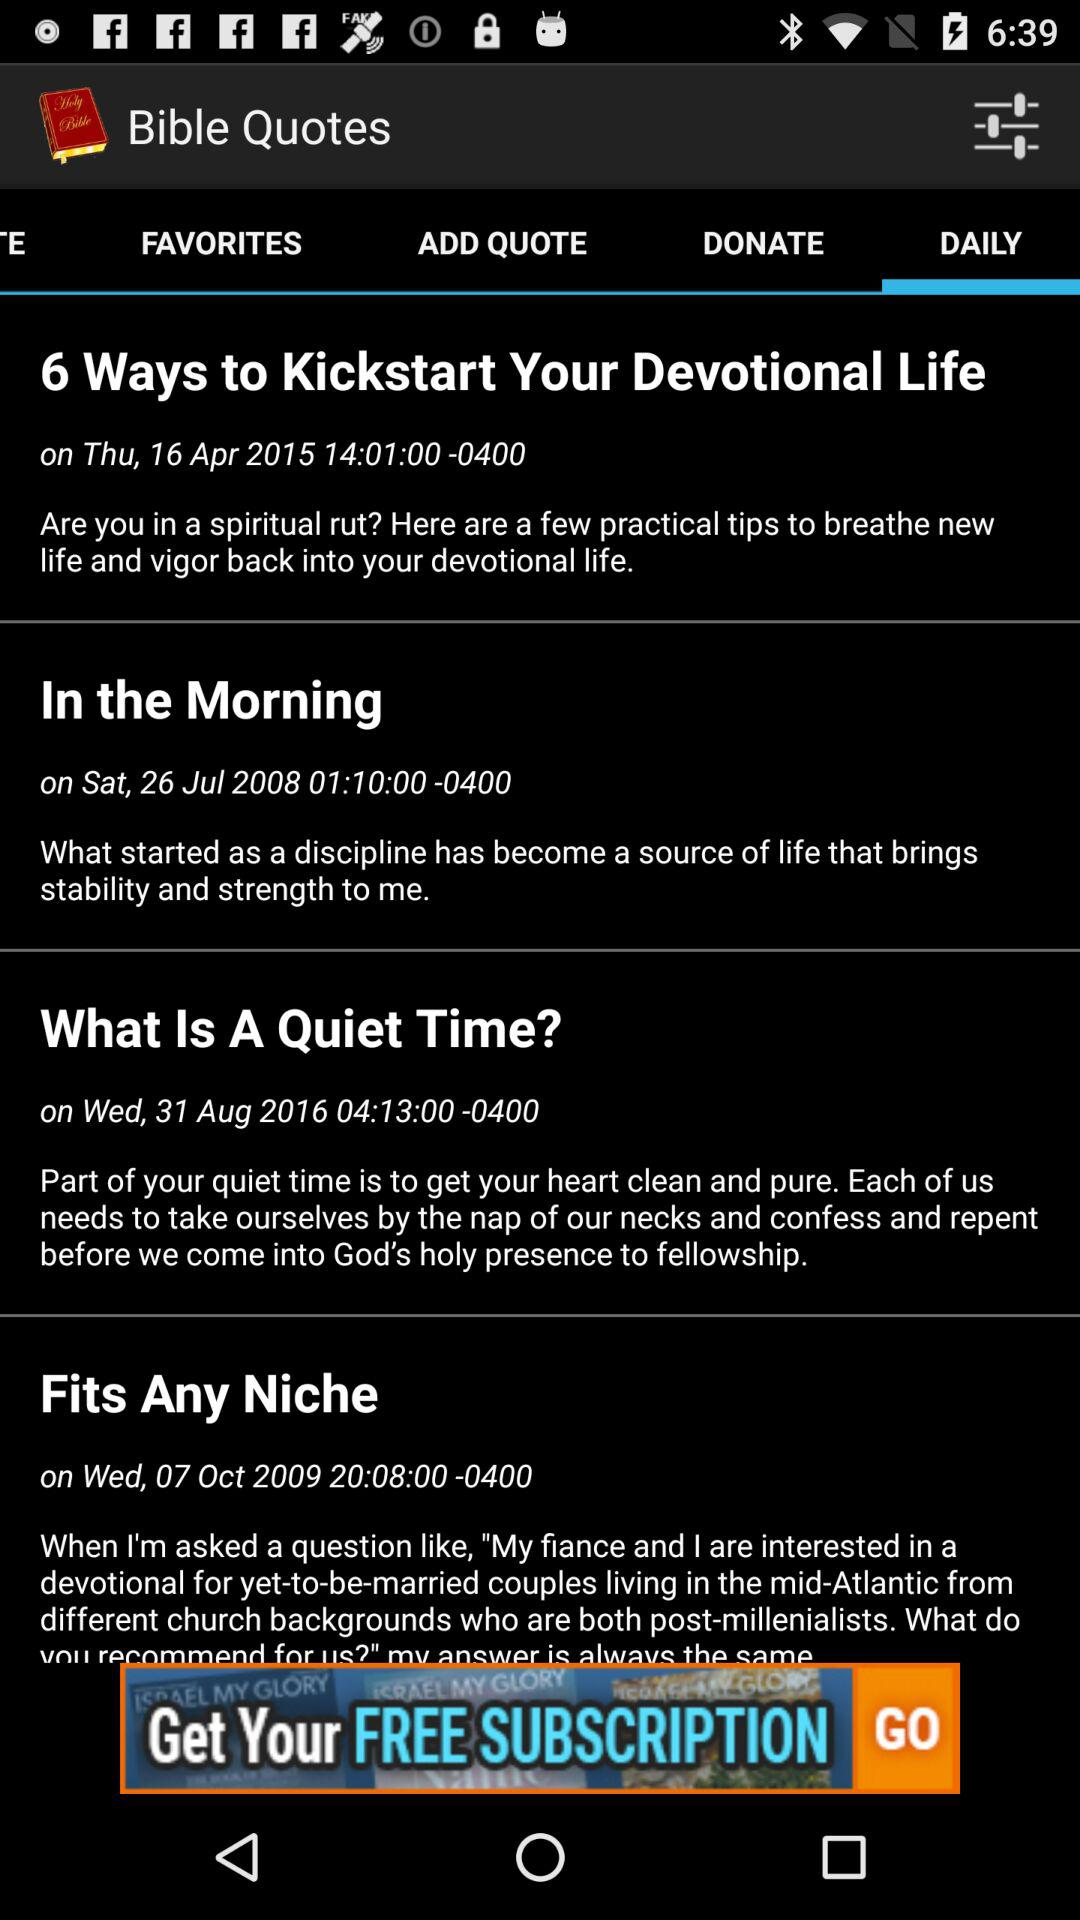At what time was the quote "What Is A Quiet Time" updated? The quote was updated at 04:13:00. 